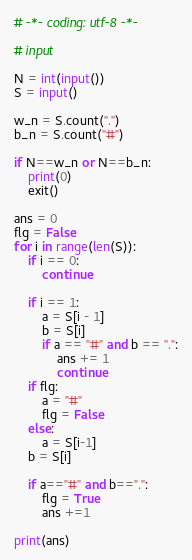<code> <loc_0><loc_0><loc_500><loc_500><_Python_># -*- coding: utf-8 -*-

# input

N = int(input())
S = input()

w_n = S.count(".")
b_n = S.count("#")

if N==w_n or N==b_n:
    print(0)
    exit()

ans = 0
flg = False
for i in range(len(S)):
    if i == 0:
        continue

    if i == 1:
        a = S[i - 1]
        b = S[i]
        if a == "#" and b == ".":
            ans += 1
            continue
    if flg:
        a = "#"
        flg = False
    else:
        a = S[i-1]
    b = S[i]

    if a=="#" and b==".":
        flg = True
        ans +=1

print(ans)</code> 